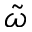<formula> <loc_0><loc_0><loc_500><loc_500>\tilde { \omega }</formula> 